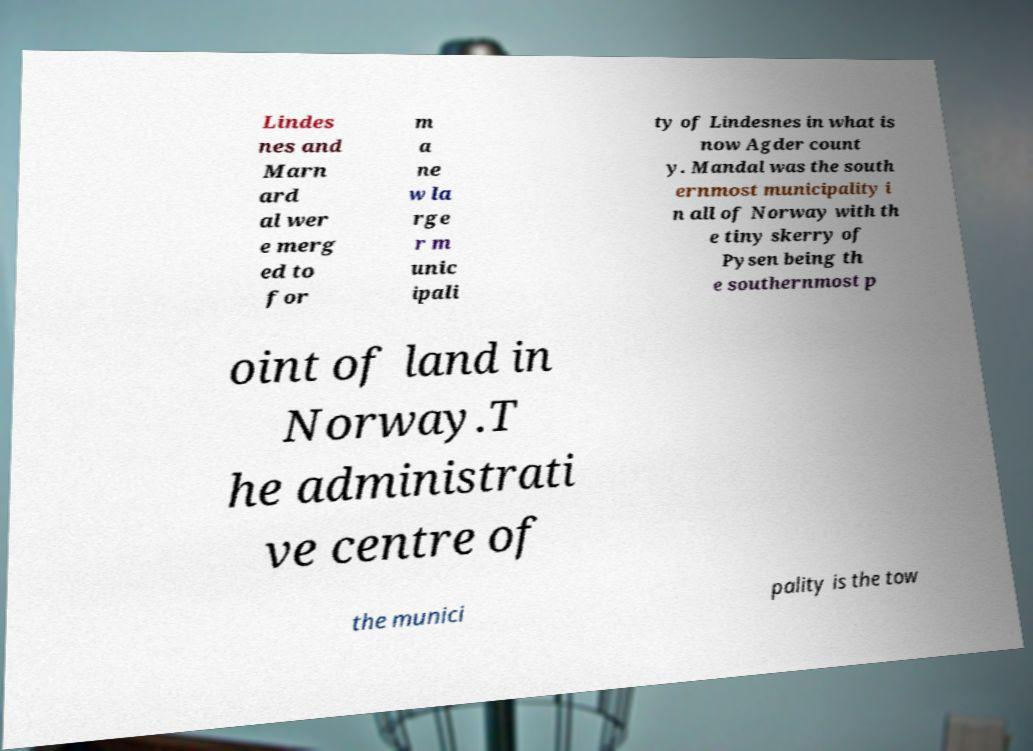Please identify and transcribe the text found in this image. Lindes nes and Marn ard al wer e merg ed to for m a ne w la rge r m unic ipali ty of Lindesnes in what is now Agder count y. Mandal was the south ernmost municipality i n all of Norway with th e tiny skerry of Pysen being th e southernmost p oint of land in Norway.T he administrati ve centre of the munici pality is the tow 